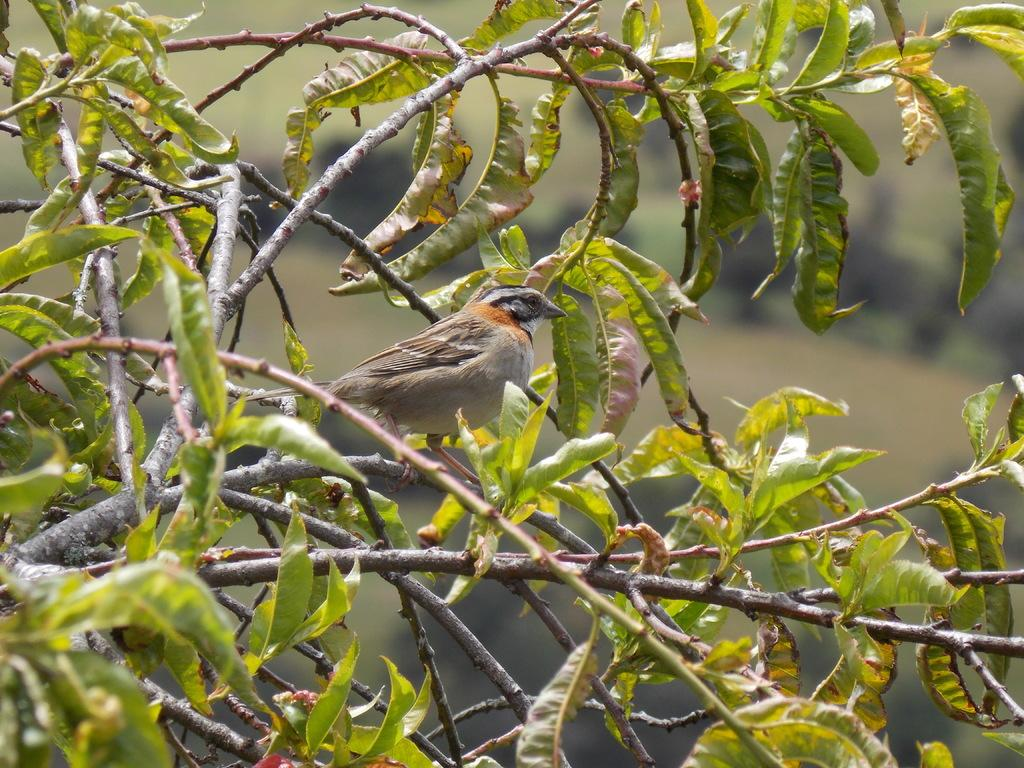What type of animal can be seen in the picture? There is a bird in the picture. What is the bird perched on in the picture? There is a tree in the picture. Can you describe the background of the image? The background of the image is blurry. Are there any statements written on the dock in the image? There is no dock present in the image, so there cannot be any statements written on it. 